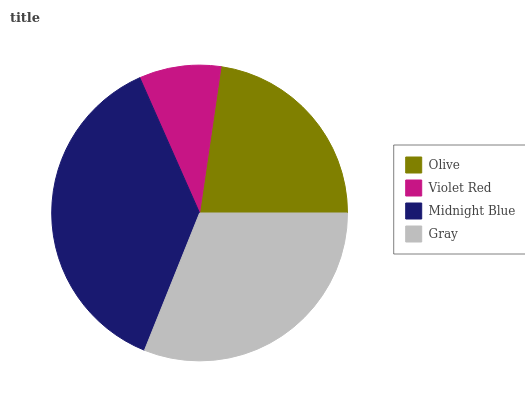Is Violet Red the minimum?
Answer yes or no. Yes. Is Midnight Blue the maximum?
Answer yes or no. Yes. Is Midnight Blue the minimum?
Answer yes or no. No. Is Violet Red the maximum?
Answer yes or no. No. Is Midnight Blue greater than Violet Red?
Answer yes or no. Yes. Is Violet Red less than Midnight Blue?
Answer yes or no. Yes. Is Violet Red greater than Midnight Blue?
Answer yes or no. No. Is Midnight Blue less than Violet Red?
Answer yes or no. No. Is Gray the high median?
Answer yes or no. Yes. Is Olive the low median?
Answer yes or no. Yes. Is Midnight Blue the high median?
Answer yes or no. No. Is Gray the low median?
Answer yes or no. No. 